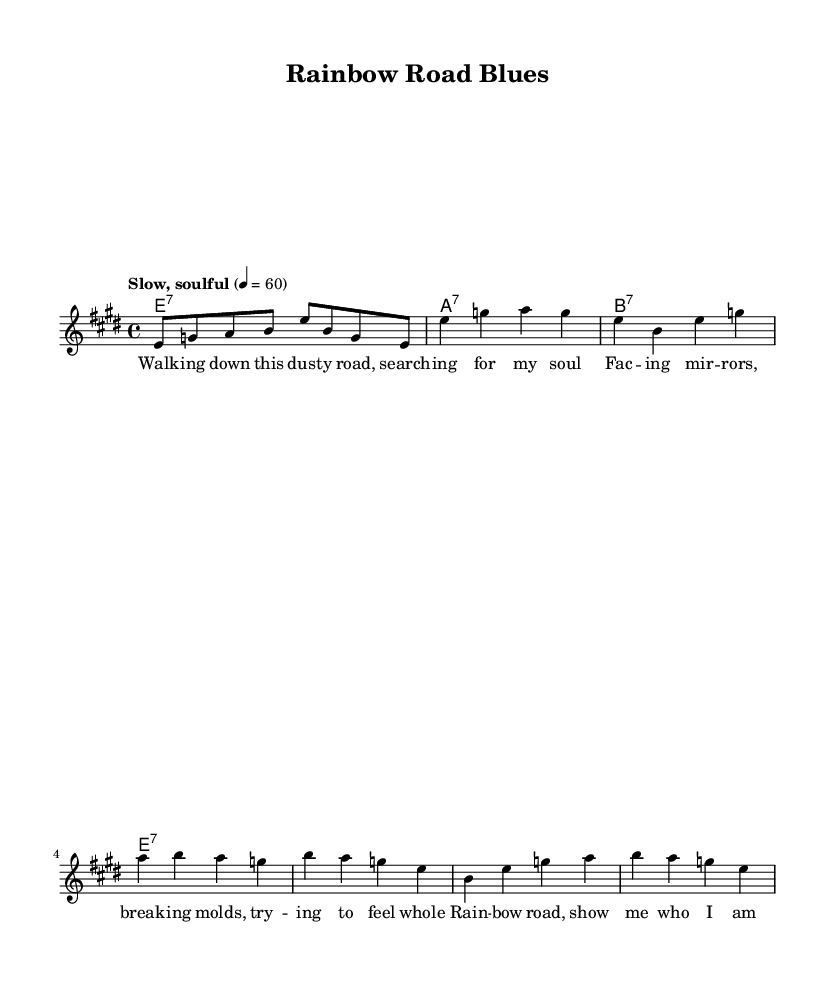What is the key signature of this music? The key signature shown is E major, which has four sharps: F#, C#, G#, and D#.
Answer: E major What is the time signature of this piece? The time signature displayed at the beginning of the score is 4/4, indicating four beats per measure.
Answer: 4/4 What is the tempo marking for this piece? The tempo marking states "Slow, soulful," which describes the mood and speed of the music to be performed.
Answer: Slow, soulful How many measures are in the verse? The verse consists of 8 measures, as suggested by the structure of the lyrics and melody within the provided sections.
Answer: 8 What chord follows the chorus? In the chord progression, the last chord played after the chorus is E7, confirming it as the resolution of the progression.
Answer: E7 What theme does this blues piece explore? The lyrics and context indicate that the theme revolves around identity and self-discovery, which is central to the piece's narrative.
Answer: Identity and self-discovery Which section contains the lyric "Rainbow road, show me who I am"? This lyric is found in the chorus section of the song, illustrating a pivotal moment in the song's expression.
Answer: Chorus 